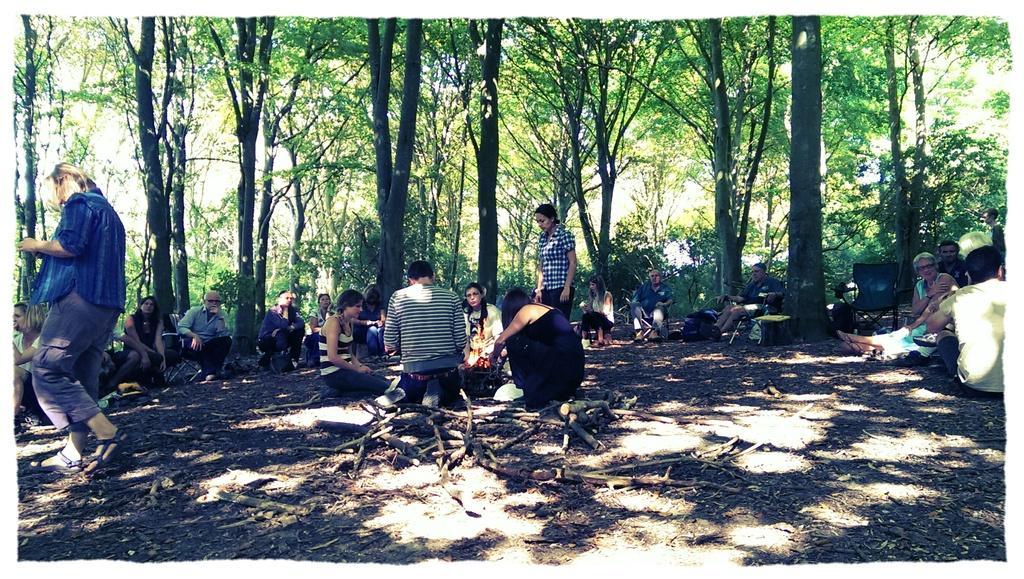In one or two sentences, can you explain what this image depicts? It is some area in between the forest, there are a lot of people sitting on the ground and at the center there are a group of people lighting the fire. 